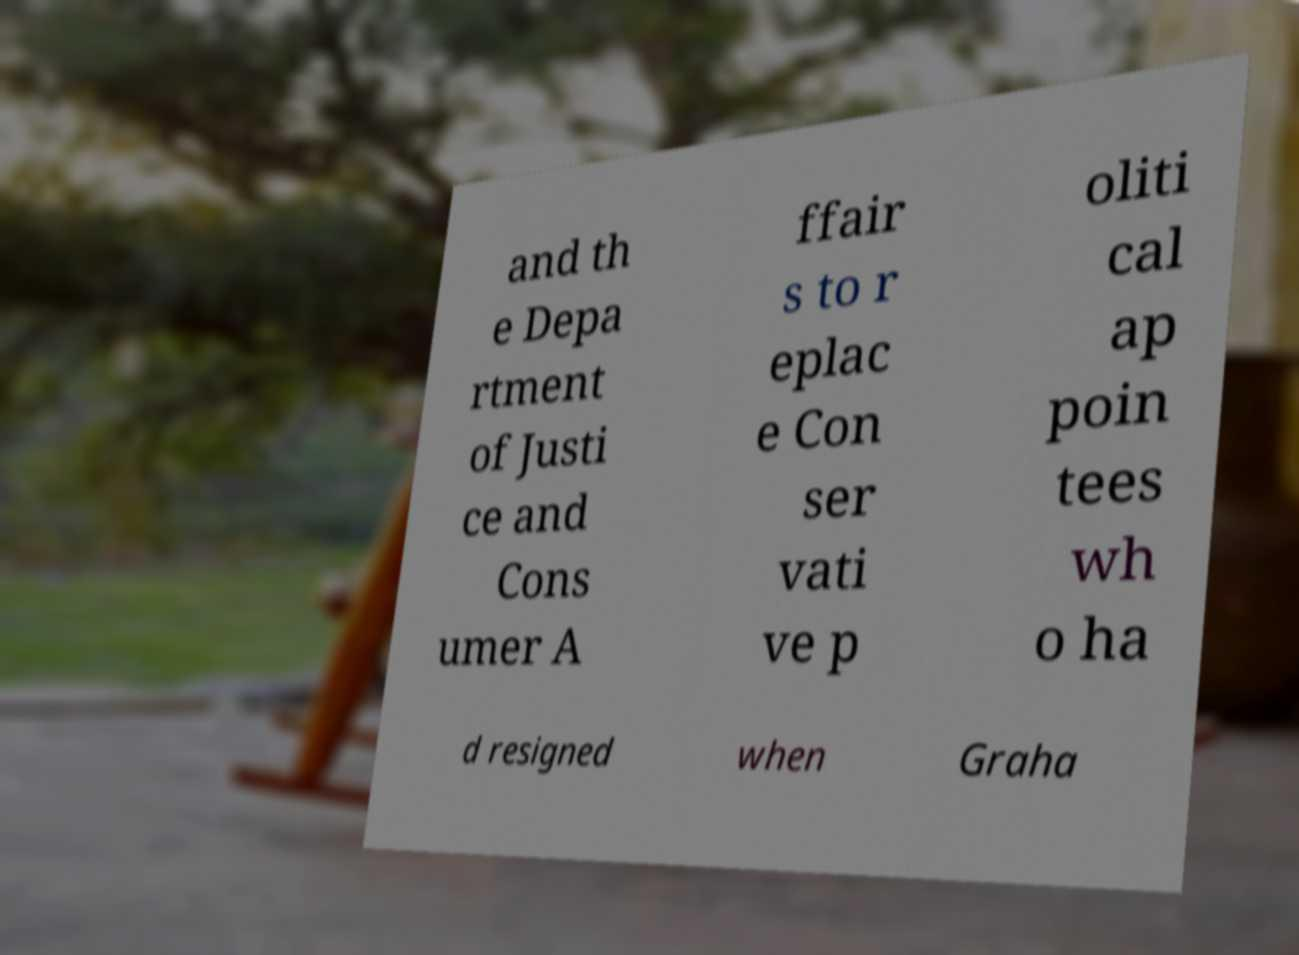Can you accurately transcribe the text from the provided image for me? and th e Depa rtment of Justi ce and Cons umer A ffair s to r eplac e Con ser vati ve p oliti cal ap poin tees wh o ha d resigned when Graha 